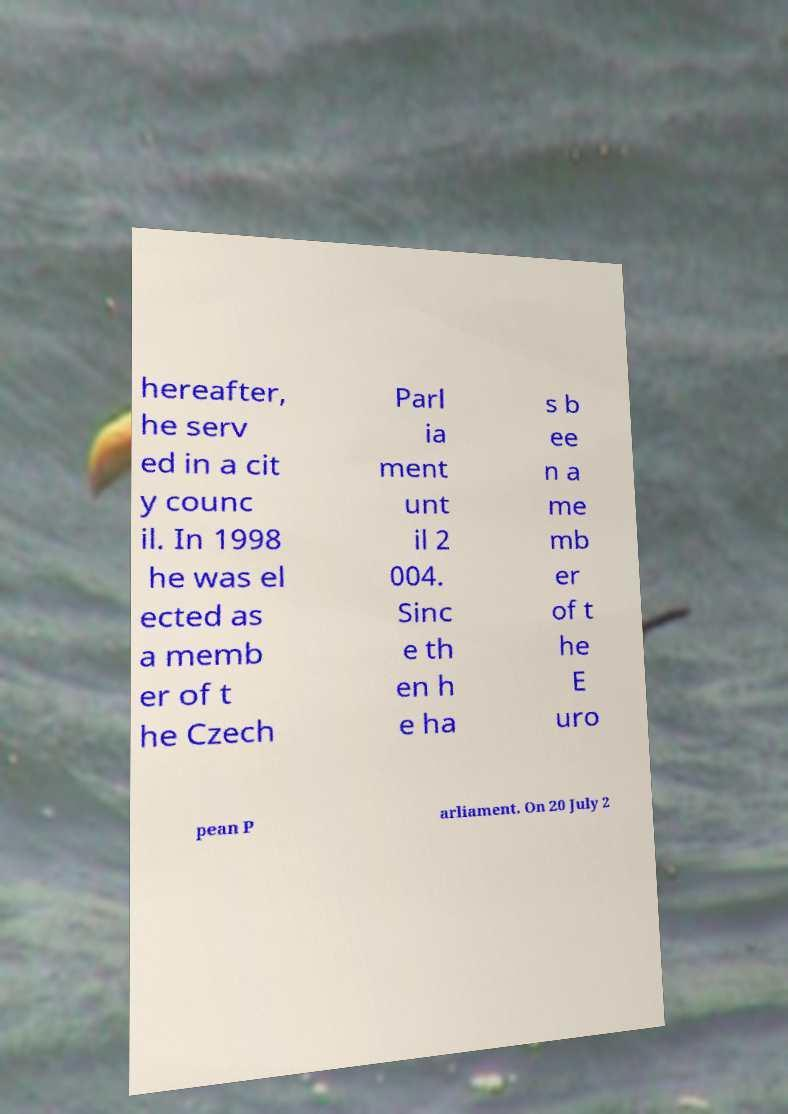Please read and relay the text visible in this image. What does it say? hereafter, he serv ed in a cit y counc il. In 1998 he was el ected as a memb er of t he Czech Parl ia ment unt il 2 004. Sinc e th en h e ha s b ee n a me mb er of t he E uro pean P arliament. On 20 July 2 